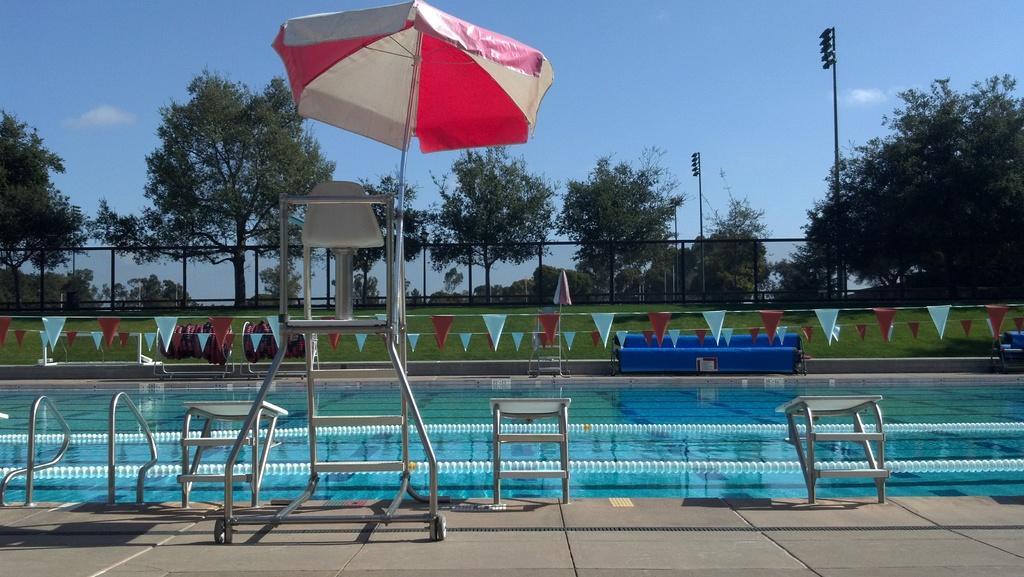Please provide a concise description of this image. As we can see in the image there is a swimming pool, an umbrella, lights, grass and trees. On the top there is sky. 